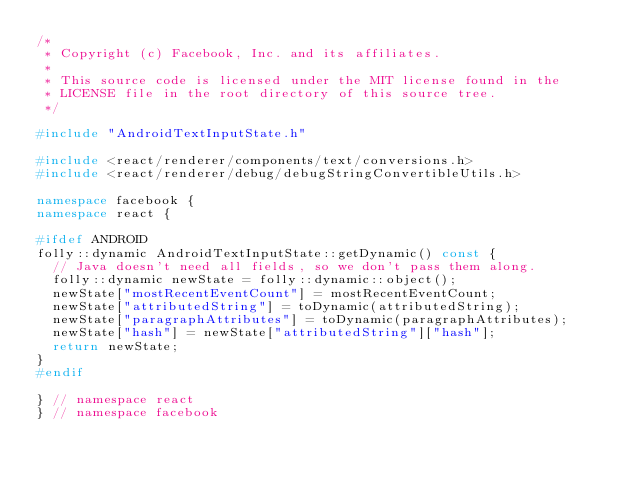<code> <loc_0><loc_0><loc_500><loc_500><_C++_>/*
 * Copyright (c) Facebook, Inc. and its affiliates.
 *
 * This source code is licensed under the MIT license found in the
 * LICENSE file in the root directory of this source tree.
 */

#include "AndroidTextInputState.h"

#include <react/renderer/components/text/conversions.h>
#include <react/renderer/debug/debugStringConvertibleUtils.h>

namespace facebook {
namespace react {

#ifdef ANDROID
folly::dynamic AndroidTextInputState::getDynamic() const {
  // Java doesn't need all fields, so we don't pass them along.
  folly::dynamic newState = folly::dynamic::object();
  newState["mostRecentEventCount"] = mostRecentEventCount;
  newState["attributedString"] = toDynamic(attributedString);
  newState["paragraphAttributes"] = toDynamic(paragraphAttributes);
  newState["hash"] = newState["attributedString"]["hash"];
  return newState;
}
#endif

} // namespace react
} // namespace facebook
</code> 